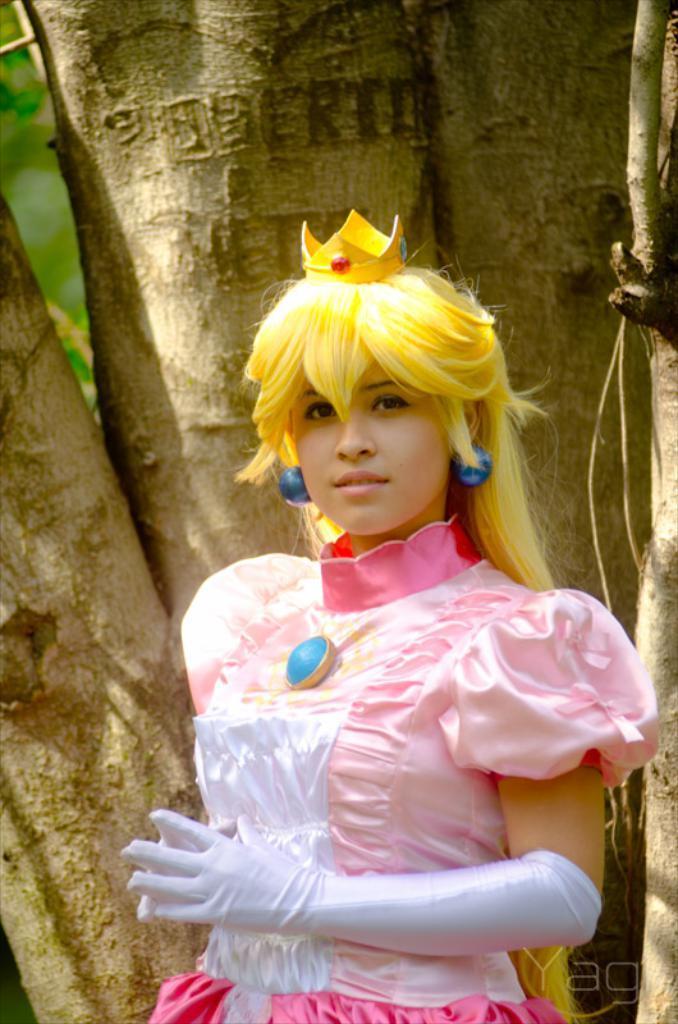Please provide a concise description of this image. In this image we can see the women wearing the hand gloves. In the background we can see the barks of a tree. In the bottom right corner we can see the text. 